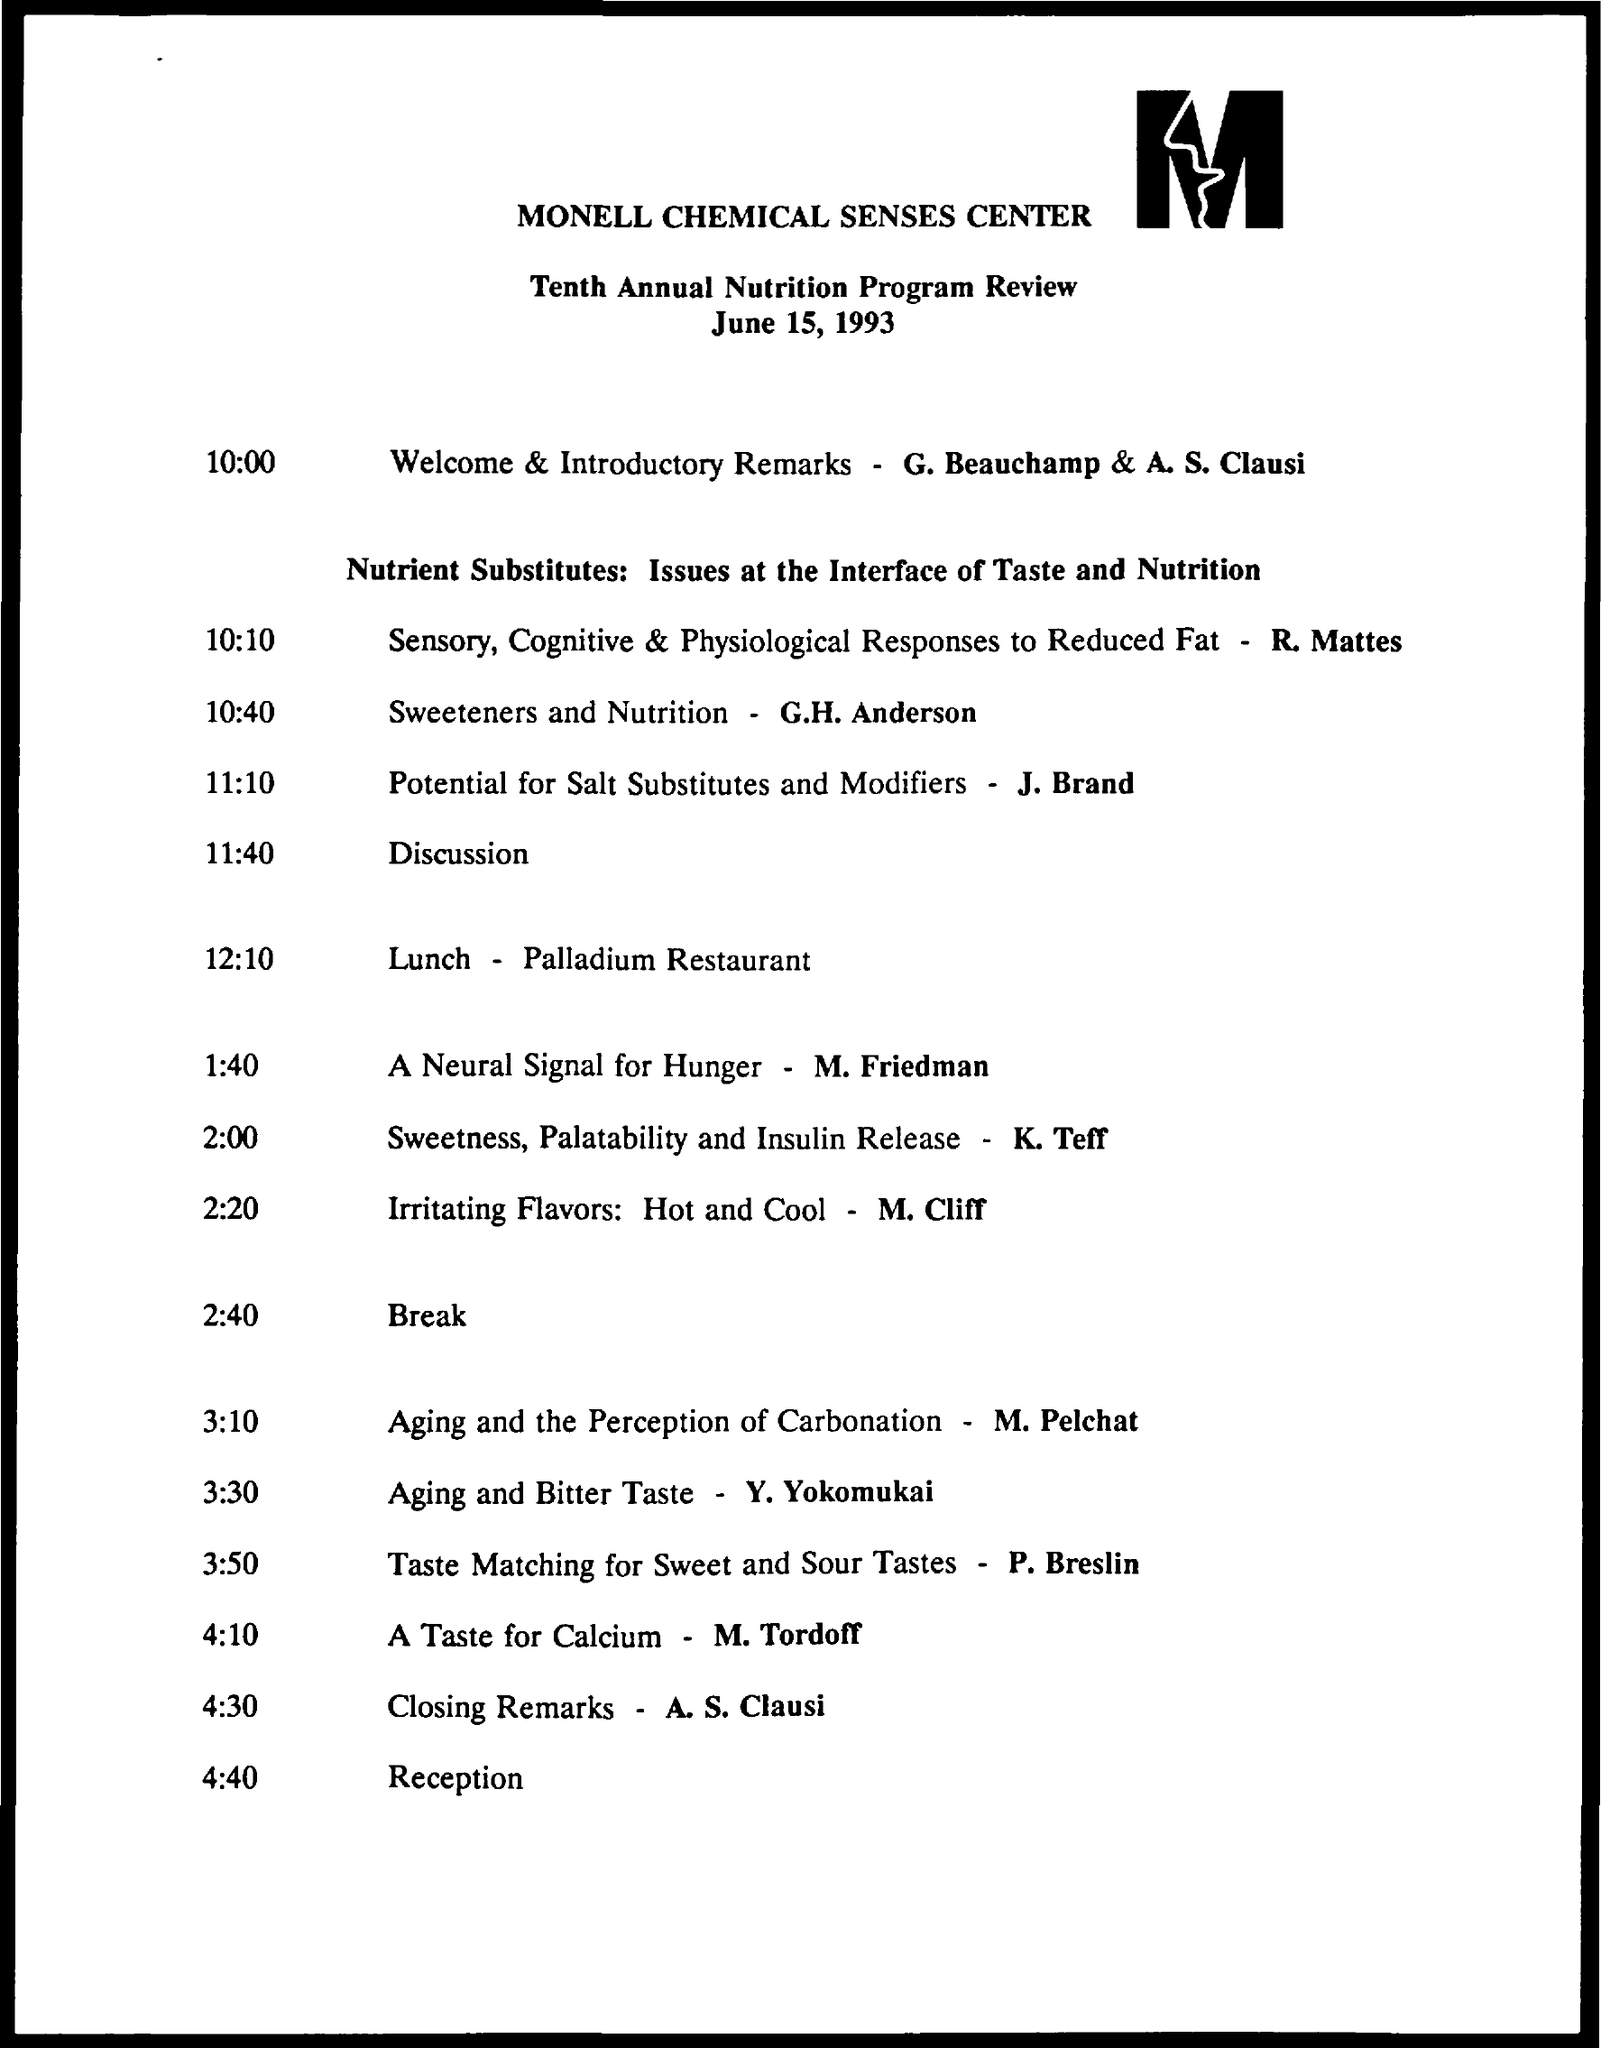Outline some significant characteristics in this image. It is stated in the discussion by M. Tordoff that "A Taste for Calcium" is given. The company named on the letterhead is the Monell Chemical Senses Center. J. Brand has presented a discussion on the potential for salt substitutes and modifiers. This agenda is made for the date of June 15, 1993. G. Beauchamp and A.S. Clausi will be delivering Welcome and Introductory Remarks at 10:00 AM. 